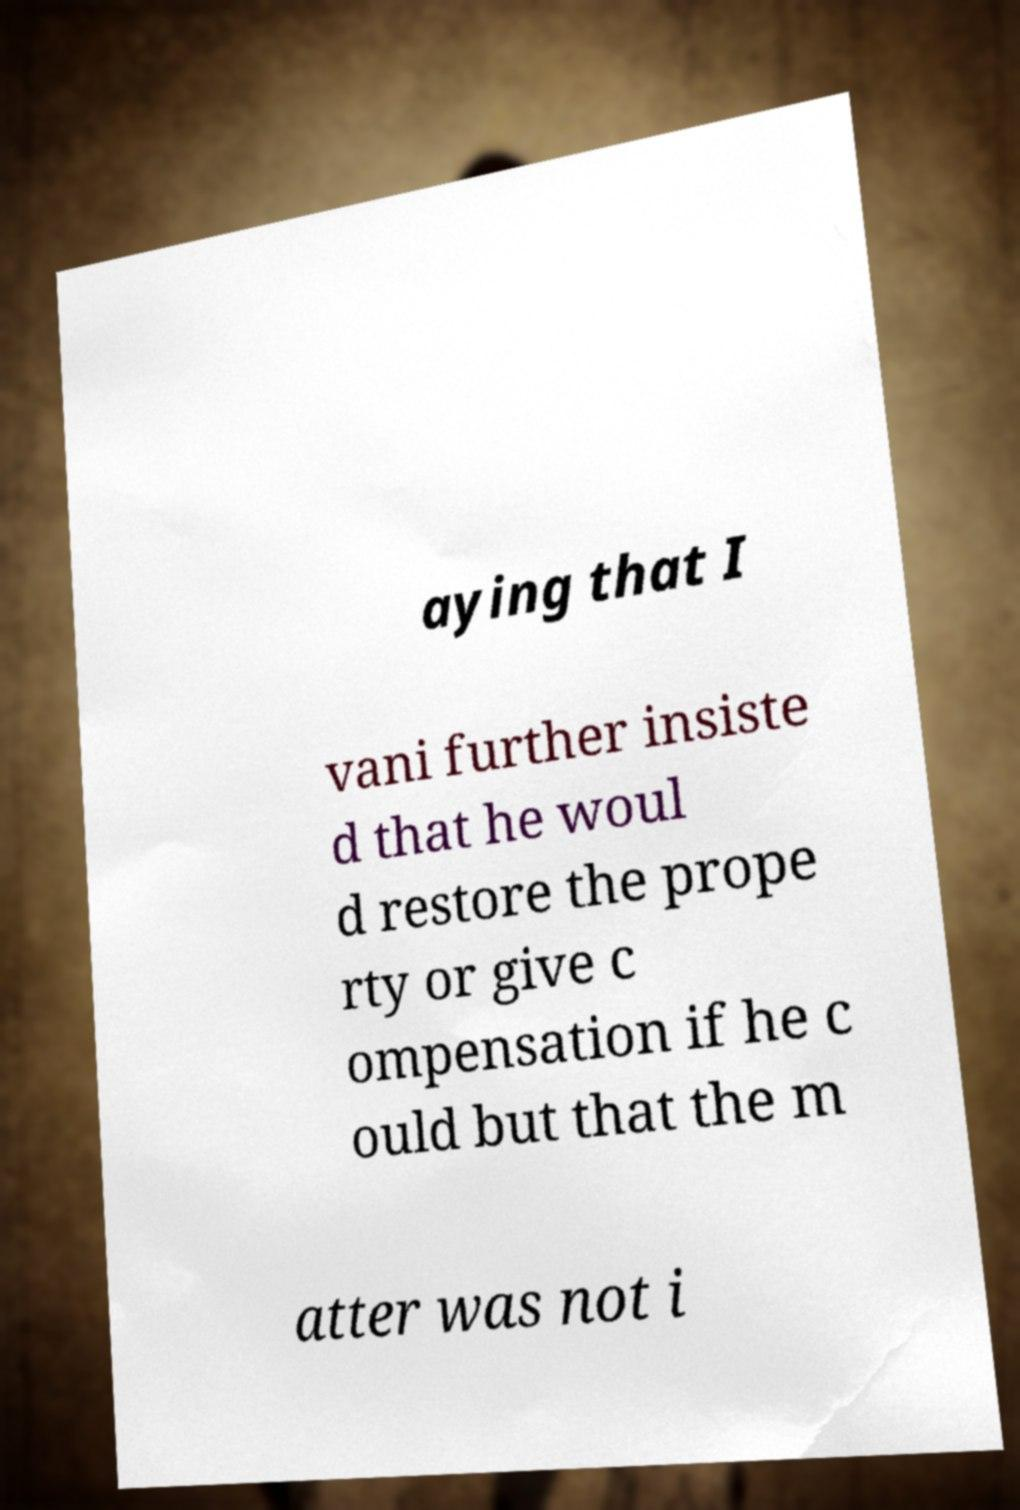I need the written content from this picture converted into text. Can you do that? aying that I vani further insiste d that he woul d restore the prope rty or give c ompensation if he c ould but that the m atter was not i 